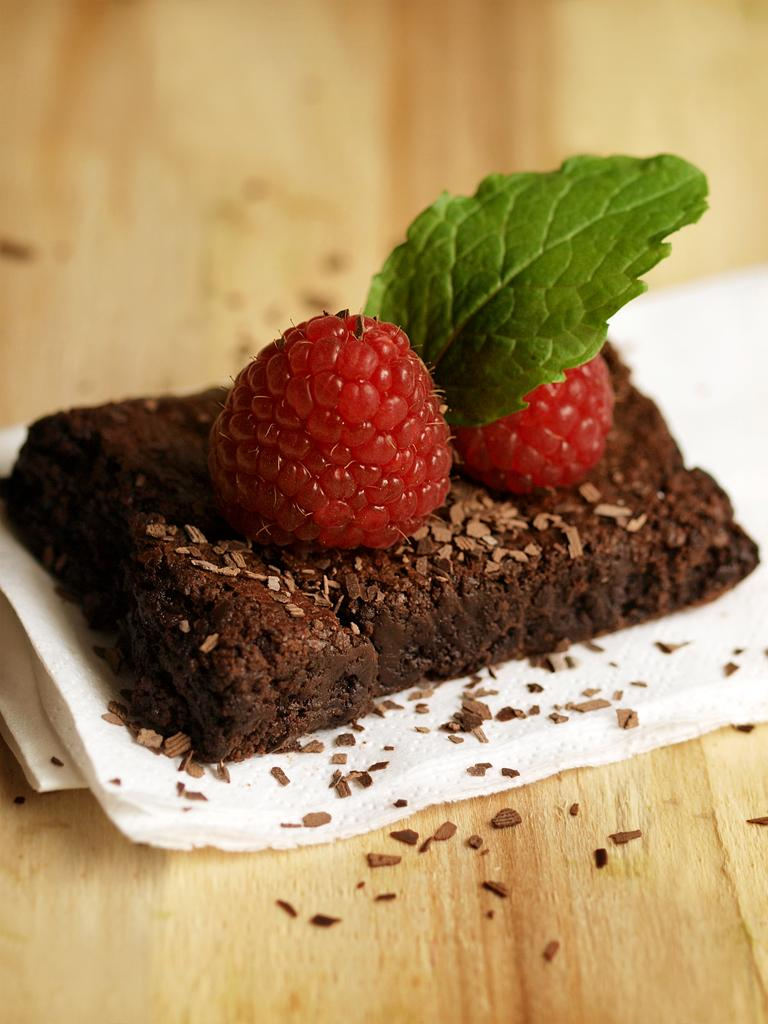What is the main subject of the image? There is a food item in the image. Where is the food item located? The food item is on a table. What type of animal can be seen shaking in the image? There is no animal present in the image, and no shaking is depicted. 